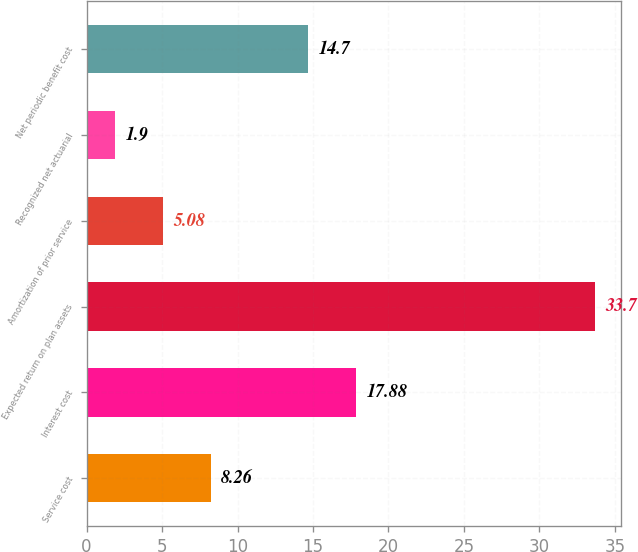Convert chart to OTSL. <chart><loc_0><loc_0><loc_500><loc_500><bar_chart><fcel>Service cost<fcel>Interest cost<fcel>Expected return on plan assets<fcel>Amortization of prior service<fcel>Recognized net actuarial<fcel>Net periodic benefit cost<nl><fcel>8.26<fcel>17.88<fcel>33.7<fcel>5.08<fcel>1.9<fcel>14.7<nl></chart> 